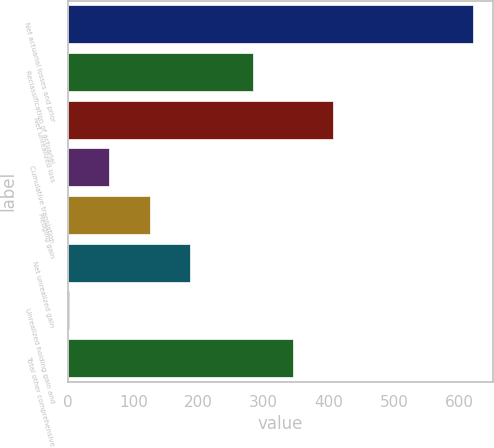Convert chart to OTSL. <chart><loc_0><loc_0><loc_500><loc_500><bar_chart><fcel>Net actuarial losses and prior<fcel>Reclassification of actuarial<fcel>Net unrealized loss<fcel>Cumulative translation<fcel>Hedging gain<fcel>Net unrealized gain<fcel>Unrealized holding gain and<fcel>Total other comprehensive<nl><fcel>621<fcel>283<fcel>407<fcel>63<fcel>125<fcel>187<fcel>1<fcel>345<nl></chart> 